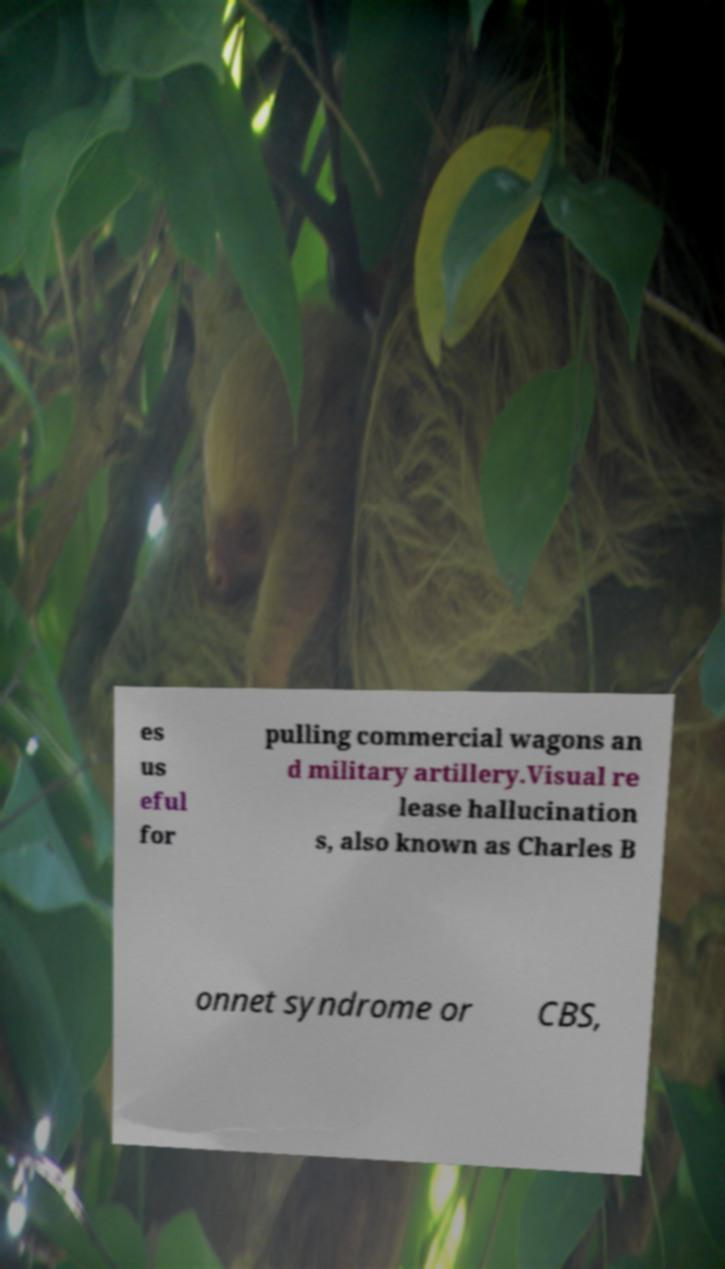What messages or text are displayed in this image? I need them in a readable, typed format. es us eful for pulling commercial wagons an d military artillery.Visual re lease hallucination s, also known as Charles B onnet syndrome or CBS, 